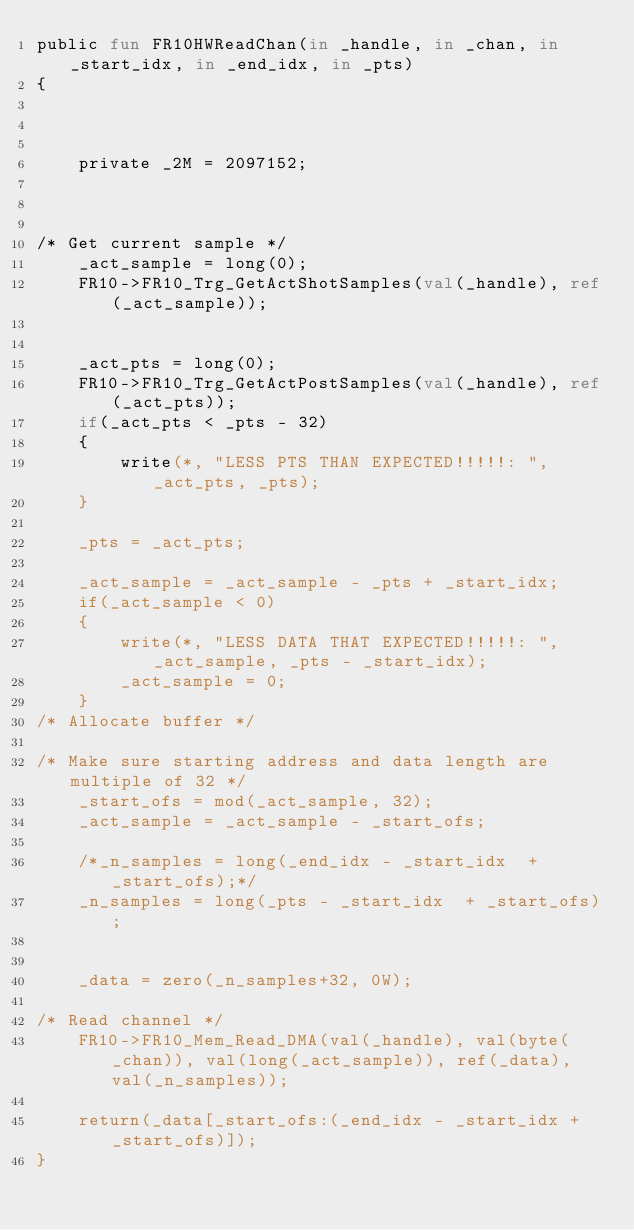Convert code to text. <code><loc_0><loc_0><loc_500><loc_500><_SML_>public fun FR10HWReadChan(in _handle, in _chan, in _start_idx, in _end_idx, in _pts)
{


	
	private _2M = 2097152;



/* Get current sample */	
	_act_sample = long(0);
	FR10->FR10_Trg_GetActShotSamples(val(_handle), ref(_act_sample));


	_act_pts = long(0);
	FR10->FR10_Trg_GetActPostSamples(val(_handle), ref(_act_pts));
	if(_act_pts < _pts - 32)
	{
	    write(*, "LESS PTS THAN EXPECTED!!!!!: ", _act_pts, _pts);
	}

	_pts = _act_pts;	

	_act_sample = _act_sample - _pts + _start_idx;
	if(_act_sample < 0)
	{
	    write(*, "LESS DATA THAT EXPECTED!!!!!: ", _act_sample, _pts - _start_idx);
	    _act_sample = 0;
	}
/* Allocate buffer */

/* Make sure starting address and data length are multiple of 32 */
	_start_ofs = mod(_act_sample, 32);
	_act_sample = _act_sample - _start_ofs; 

	/*_n_samples = long(_end_idx - _start_idx  + _start_ofs);*/
	_n_samples = long(_pts - _start_idx  + _start_ofs);
	

	_data = zero(_n_samples+32, 0W);

/* Read channel */
	FR10->FR10_Mem_Read_DMA(val(_handle), val(byte(_chan)), val(long(_act_sample)), ref(_data), val(_n_samples));

	return(_data[_start_ofs:(_end_idx - _start_idx + _start_ofs)]);
}

	

</code> 